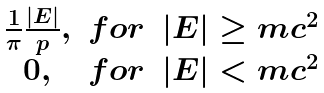Convert formula to latex. <formula><loc_0><loc_0><loc_500><loc_500>\begin{matrix} \frac { 1 } { \pi } \frac { | E | } { p } , & f o r & | E | \geq m c ^ { 2 } \\ 0 , & f o r & | E | < m c ^ { 2 } \\ \end{matrix}</formula> 